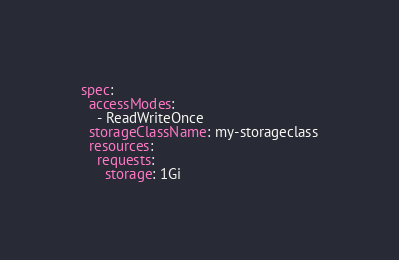Convert code to text. <code><loc_0><loc_0><loc_500><loc_500><_YAML_>spec:
  accessModes:
    - ReadWriteOnce
  storageClassName: my-storageclass
  resources:
    requests:
      storage: 1Gi
</code> 